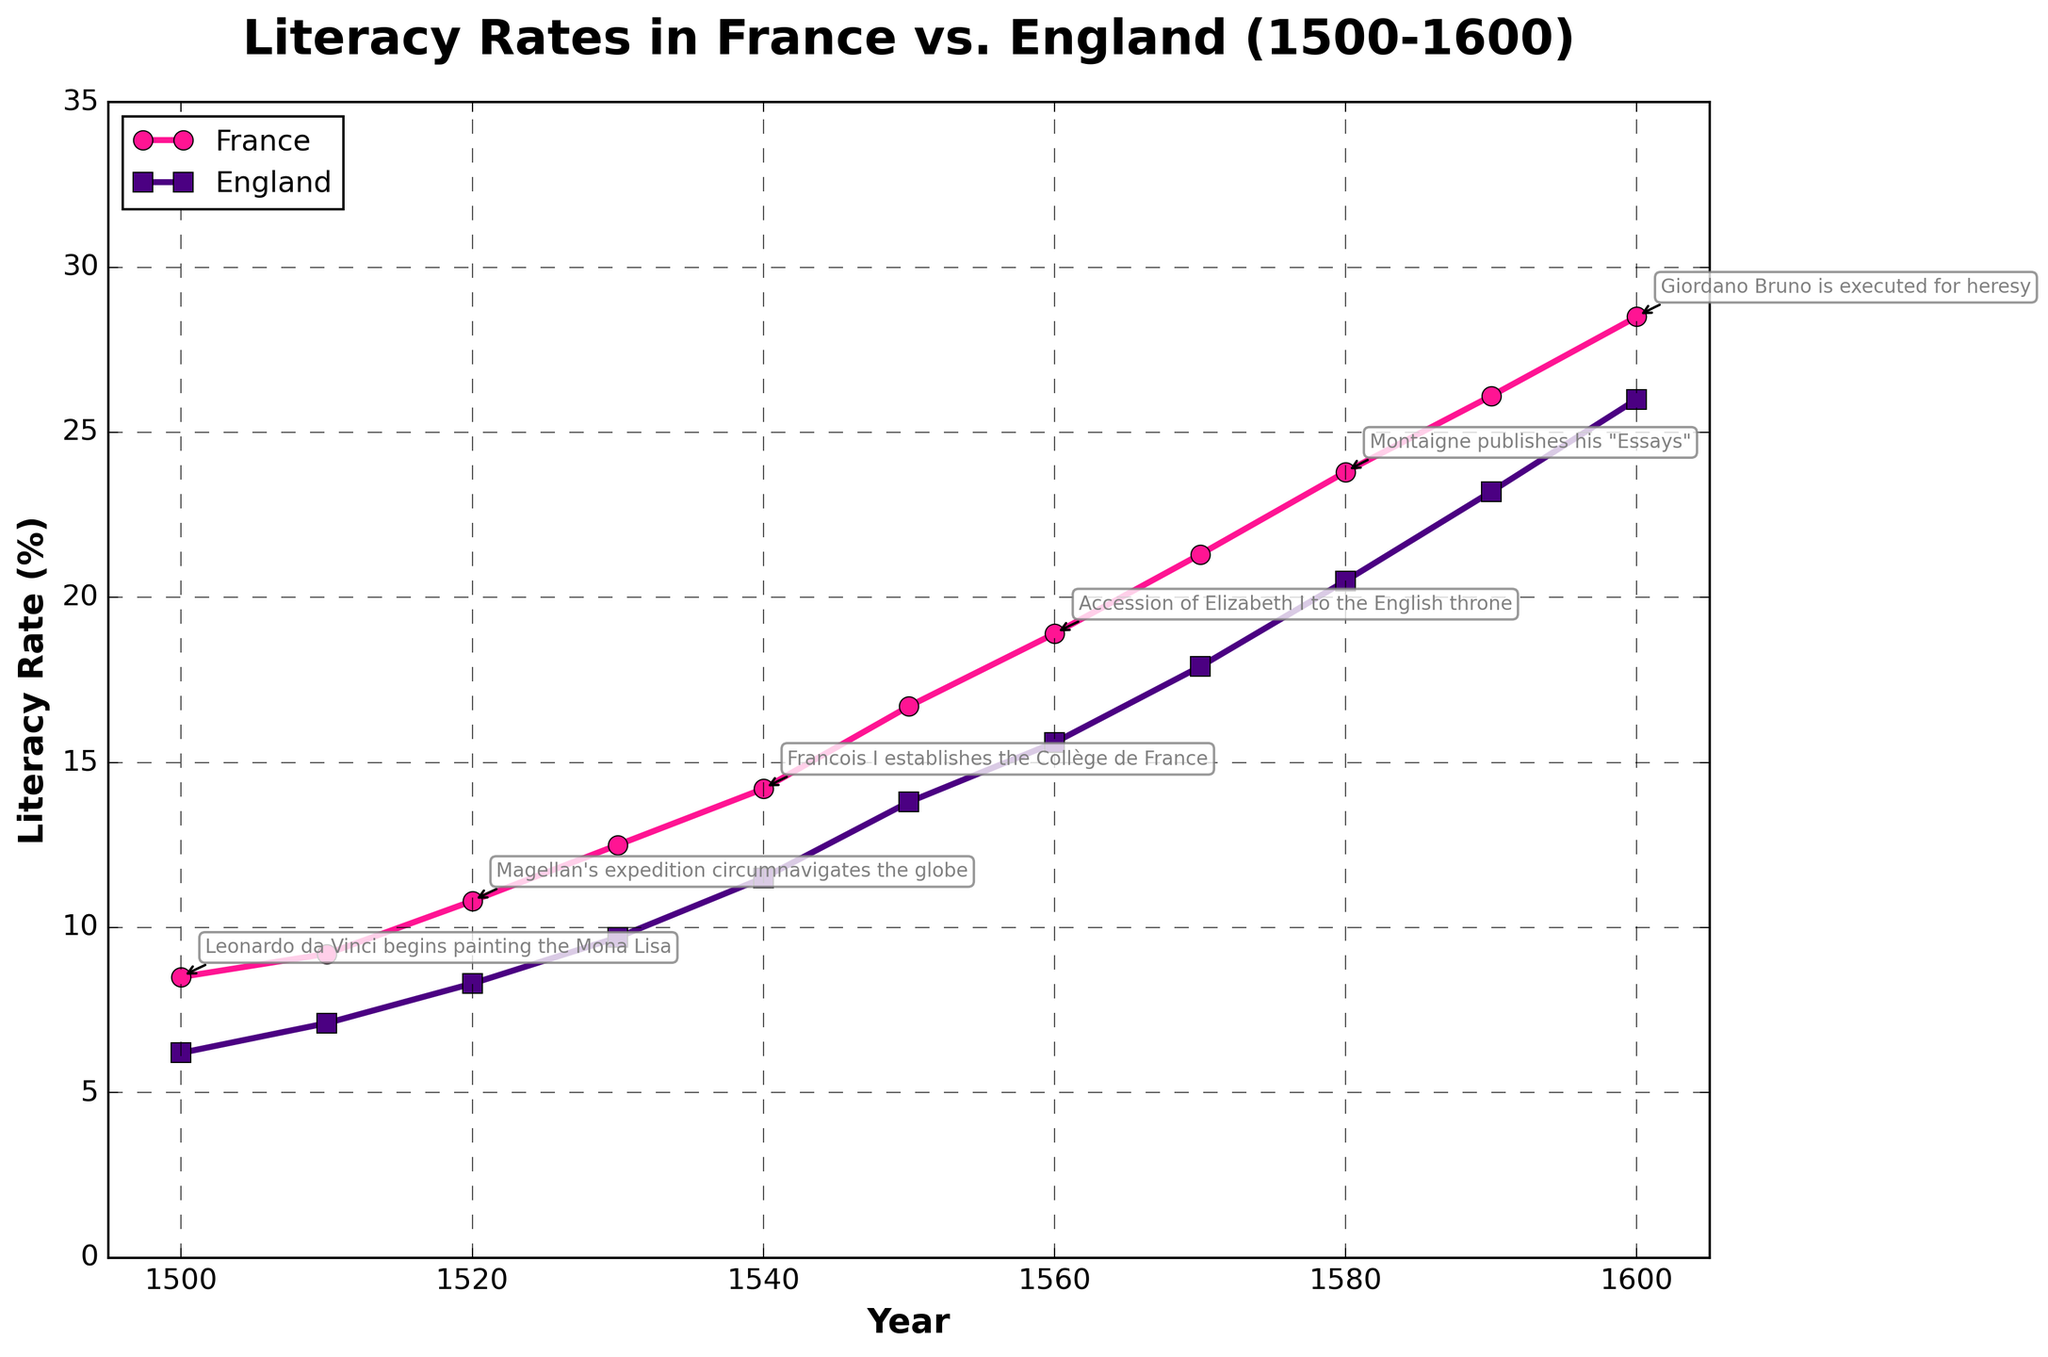What is the difference in literacy rates between France and England in 1500? From the figure, the literacy rate in France in 1500 is 8.5%, and in England, it is 6.2%. The difference can be calculated as 8.5% - 6.2% = 2.3%.
Answer: 2.3% By how much did the literacy rate in England increase from 1500 to 1600? In 1500, the literacy rate in England was 6.2%. In 1600, it was 26.0%. The increase can be calculated as 26.0% - 6.2% = 19.8%.
Answer: 19.8% Which country had a higher literacy rate in 1540, and by how much? In 1540, the literacy rates were 14.2% for France and 11.5% for England. France had a higher literacy rate by 14.2% - 11.5% = 2.7%.
Answer: France by 2.7% Which notable Renaissance event is associated with the year 1530 on the chart? The figure annotates notable events, and for the year 1530, the event listed is "Henry VIII breaks from the Catholic Church."
Answer: Henry VIII breaks from the Catholic Church How much did the literacy rate in France change from 1580 to 1590? In 1580, the literacy rate in France was 23.8%. By 1590, it increased to 26.1%. The change can be calculated as 26.1% - 23.8% = 2.3%.
Answer: 2.3% Compare the overall trend of literacy rates in both France and England from 1500 to 1600. Both countries show a general increasing trend in literacy rates. However, France consistently maintains a higher rate than England throughout the century.
Answer: France consistently higher, both increasing At what year did France's literacy rate reach approximately double that of England's literacy rate in 1500? England's literacy rate in 1500 was 6.2%. Doubling this rate gives approximately 12.4%. By checking the chart, France's literacy rate reached 12.5% in 1530.
Answer: 1530 What was the literacy rate in England when Francois I established the Collège de France in 1540? According to the chart, Francois I established the Collège de France in 1540, and the literacy rate in England at that time was 11.5%.
Answer: 11.5% Identify the period when the literacy rate growth in France was the most rapid. Observing the slope of the line in the figure, the most rapid increase in France's literacy rate occurs between 1550 and 1600.
Answer: 1550 to 1600 When did England's literacy rate surpass 20%, and which notable Renaissance event occurred around that time? From the chart, we see that England's literacy rate surpassed 20% in 1580, with the notable event being "Montaigne publishes his 'Essays'."
Answer: 1580, Montaigne publishes his "Essays" 